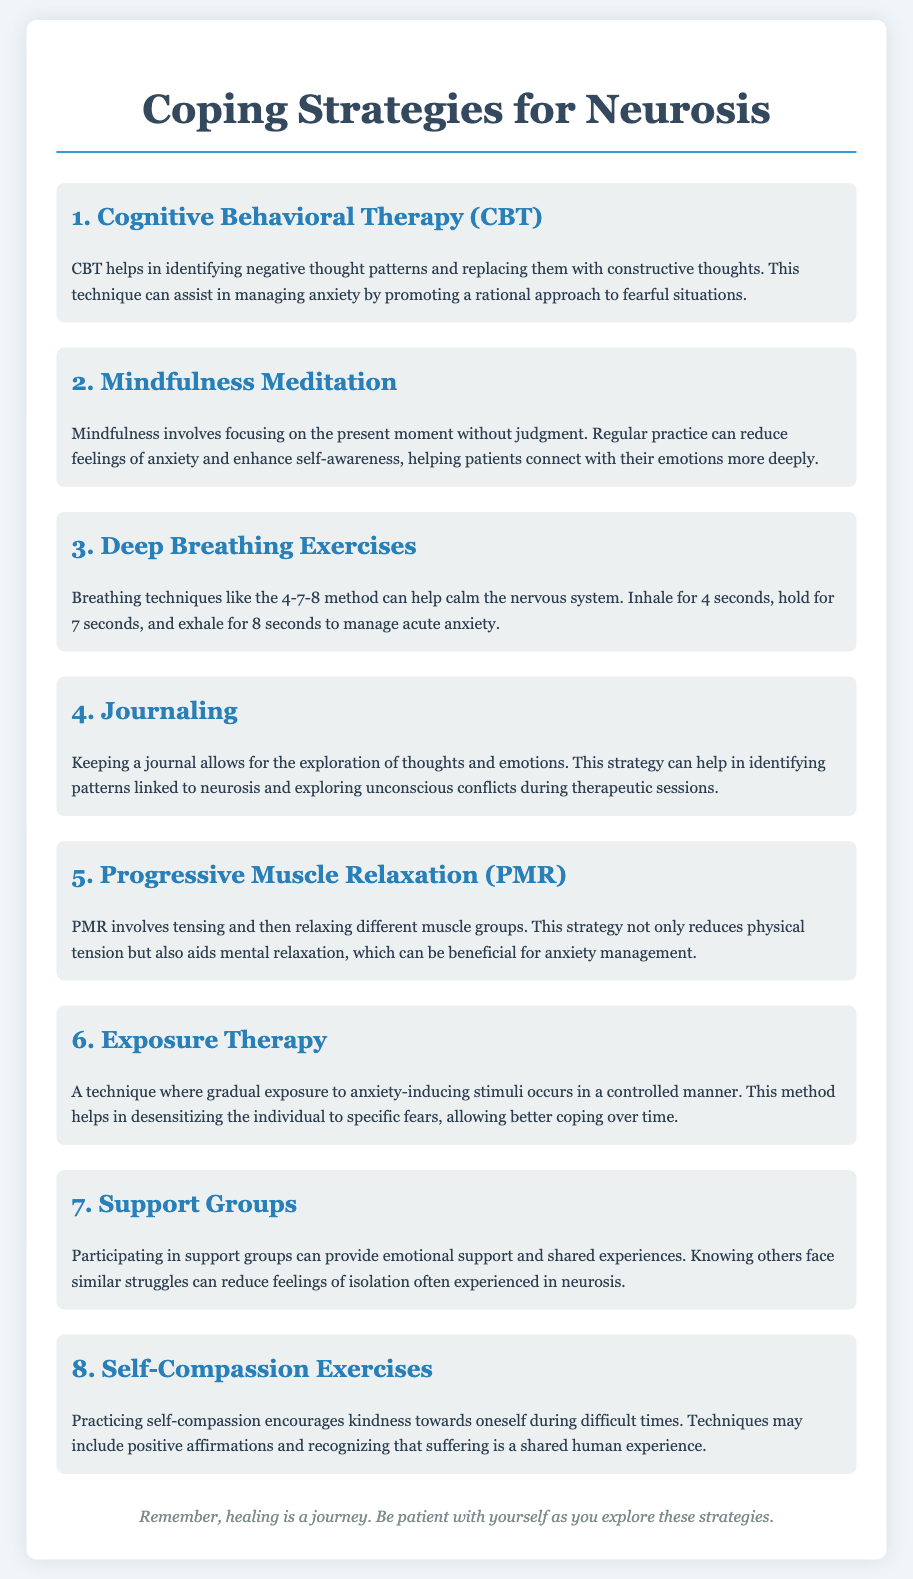What is the first coping strategy listed? The first coping strategy listed in the document is Cognitive Behavioral Therapy (CBT).
Answer: Cognitive Behavioral Therapy (CBT) How many breathing techniques are mentioned? The document specifically mentions one breathing technique, the 4-7-8 method, under deep breathing exercises.
Answer: One What do support groups provide? Support groups provide emotional support and shared experiences to individuals managing neurosis.
Answer: Emotional support Which strategy helps in identifying negative thought patterns? The strategy that helps in identifying negative thought patterns is Cognitive Behavioral Therapy (CBT).
Answer: Cognitive Behavioral Therapy (CBT) What color is used for the header text in the document? The header text color used in the document is #34495e according to the style rules.
Answer: #34495e What is the purpose of journaling according to the document? Journaling allows for the exploration of thoughts and emotions, helping in identifying patterns linked to neurosis.
Answer: Exploration of thoughts and emotions Which technique involves tensing and relaxing muscle groups? The technique that involves tensing and relaxing different muscle groups is Progressive Muscle Relaxation (PMR).
Answer: Progressive Muscle Relaxation (PMR) How many coping strategies are listed in total? The document lists a total of eight coping strategies for managing anxiety and neurosis.
Answer: Eight 